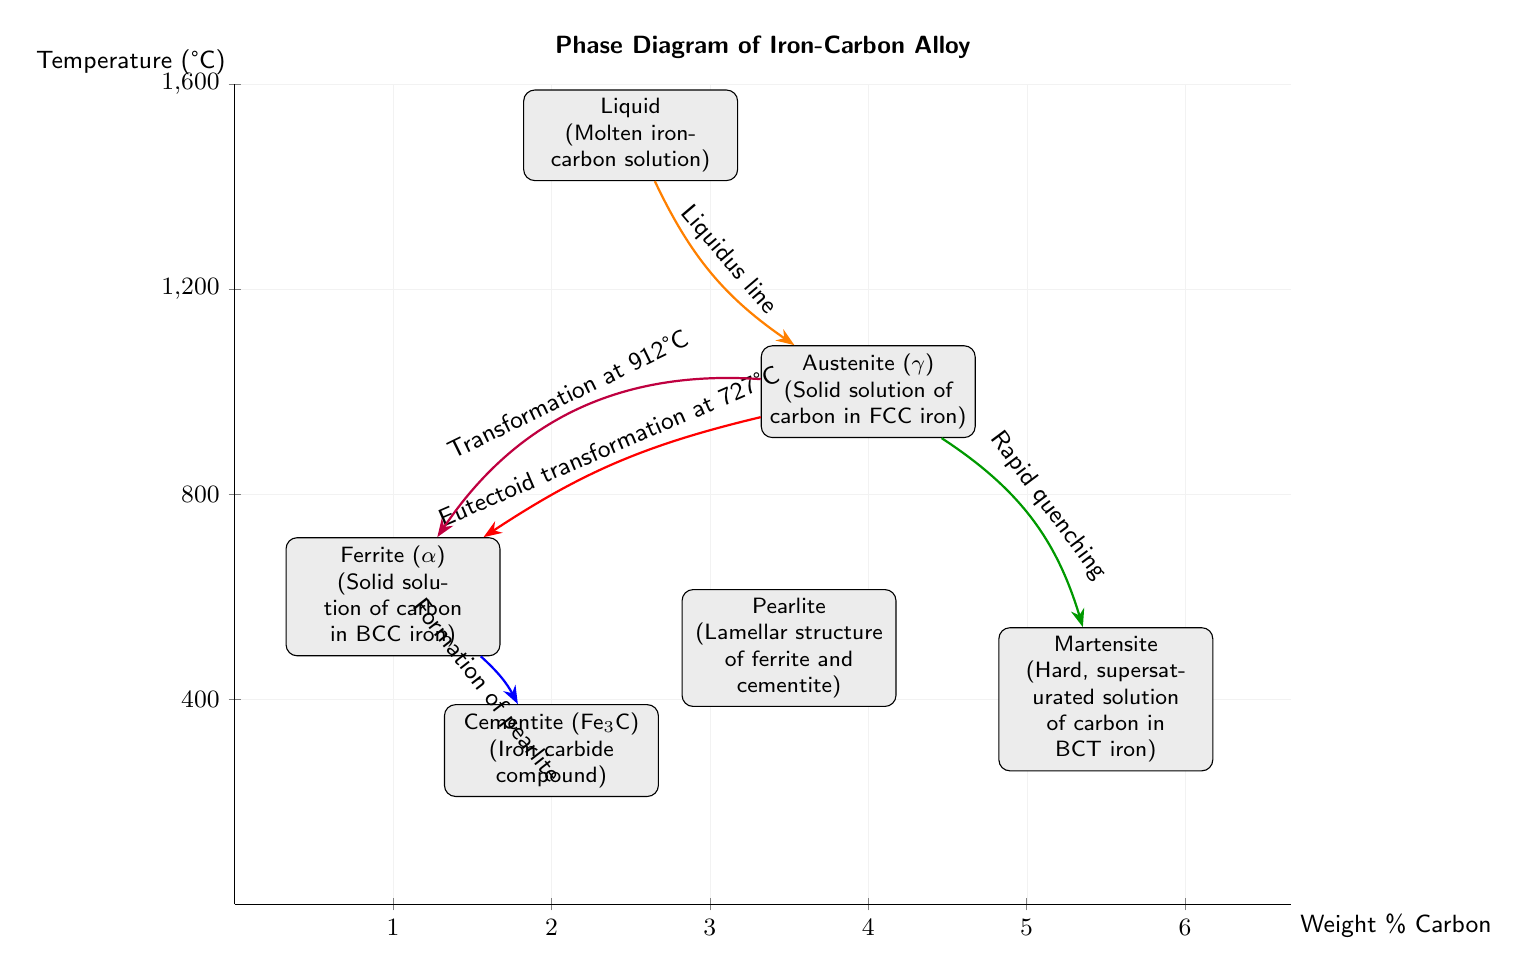What is the melting point of the iron-carbon alloy in this diagram? The melting point is indicated by the intersection of the liquidus line and the vertical axis. The highest temperature where the liquid phase exists in the diagram is around 1500 degrees Celsius.
Answer: 1500 degrees Celsius What phase is found at 727 degrees Celsius? At 727 degrees Celsius, the diagram shows a eutectoid transformation occurring from austenite to ferrite and cementite, indicating the phase present during this transformation is austenite.
Answer: Austenite How many distinct phases are labeled in the diagram? The diagram contains six distinct phases labeled: Liquid, Ferrite, Austenite, Cementite, Pearlite, and Martensite, counted directly from the nodes.
Answer: Six What are the two phases that form during the eutectoid transformation? The eutectoid transformation occurs from austenite at 727 degrees Celsius and results in the formation of ferrite and cementite, as indicated by the arrows showing the transformation.
Answer: Ferrite and Cementite Which phase is represented by the node on the left side of the diagram? The node on the left side represents Ferrite, as it is positioned at a lower temperature and a lower carbon percentage compared to other phases like austenite and cementite.
Answer: Ferrite What process is represented by the transformation from austenite to martensite? The transition from austenite to martensite is attributed to the process of rapid quenching, as explained by the directed edge in the diagram.
Answer: Rapid quenching What structure does pearlite represent in this phase diagram? Pearlite in the phase diagram is depicted as a lamellar structure formed from the combination of ferrite and cementite, as indicated by its identified position and description.
Answer: Lamellar structure of ferrite and cementite At what weight percent of carbon is the cementite phase found? The cementite phase appears in the diagram at approximately 2 weight percent carbon. The x-coordinate of the cementite node indicates this specific carbon content.
Answer: Two weight percent What temperature does the transformation from austenite to ferrite occur? The transformation from austenite to ferrite occurs at 912 degrees Celsius, as indicated by the transformation label along the edge in the diagram.
Answer: 912 degrees Celsius 